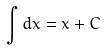Convert formula to latex. <formula><loc_0><loc_0><loc_500><loc_500>\int d x = x + C</formula> 